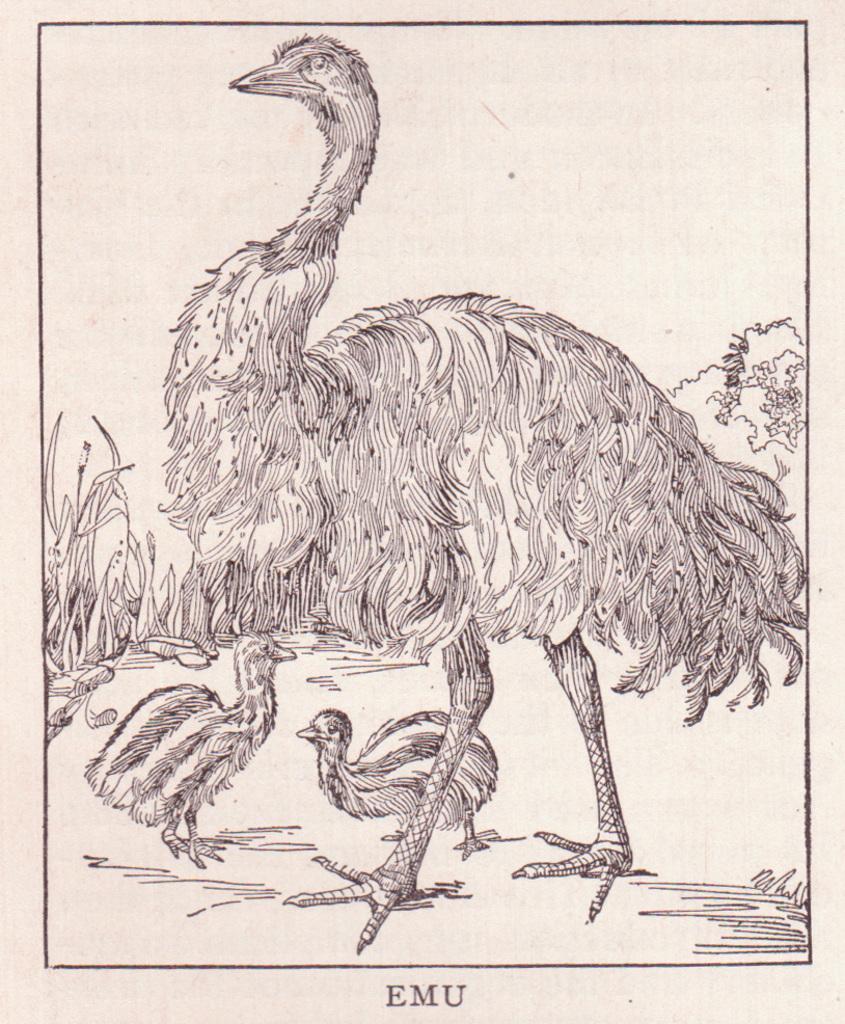Please provide a concise description of this image. In this image I can see a sketch of few birds and trees. Background is in white color. 